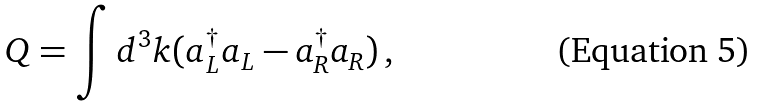Convert formula to latex. <formula><loc_0><loc_0><loc_500><loc_500>Q = \int d ^ { 3 } k ( a ^ { \dag } _ { L } a _ { L } - a ^ { \dag } _ { R } a _ { R } ) \, ,</formula> 